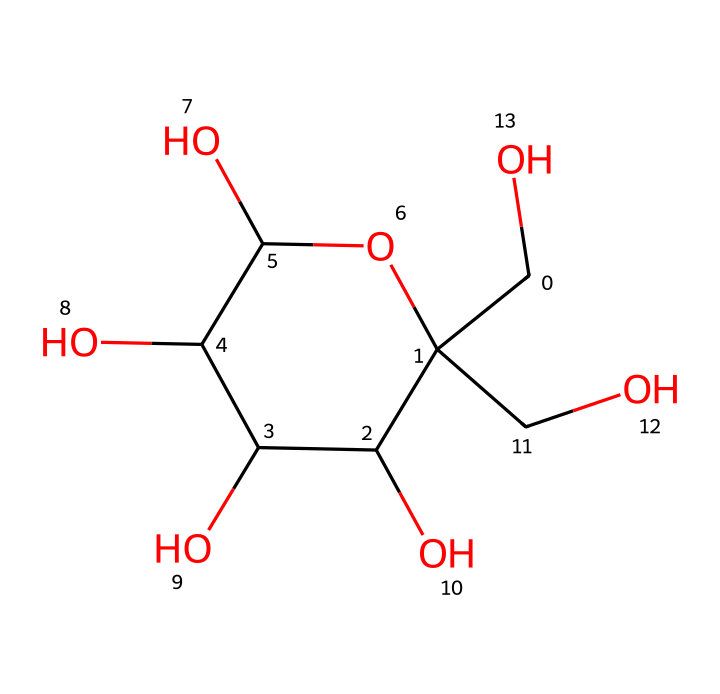What is the molecular formula of fructose? To determine the molecular formula from the SMILES representation, count the number of each type of atom present. The structure contains 6 carbon (C) atoms, 12 hydrogen (H) atoms, and 6 oxygen (O) atoms, which gives the formula C6H12O6.
Answer: C6H12O6 How many hydroxyl (–OH) groups are present in fructose? Examine the structure to identify the –OH (hydroxyl) groups. In the provided SMILES representation, there are 5 occurrences of –OH groups attached to carbon atoms, indicating that there are 5 hydroxyl groups.
Answer: 5 Is fructose a monosaccharide or a polysaccharide? Based on the structure, fructose consists of a single sugar unit, which classifies it as a monosaccharide. Polysaccharides are made up of multiple monosaccharide units linked together.
Answer: monosaccharide What type of carbohydrate is fructose categorized under? Fructose is categorized as a simple sugar, specifically a ketose, because it contains a ketone functional group in its structure and is a monomer of carbohydrates.
Answer: ketose How many chiral centers does fructose have? To determine the number of chiral centers, locate the carbon atoms that have four different substituents in the structure. Fructose has three chiral centers at carbons 3, 4, and 5, where each has different groups attached.
Answer: 3 What is one common use of fructose in beverages? Fructose is often used as a sweetener in energy drinks because it is sweeter than glucose and can enhance flavor without adding significant calories.
Answer: sweetener What effect does fructose have on blood sugar levels? Fructose has a lower glycemic index compared to glucose, meaning it causes a slower increase in blood sugar levels after consumption.
Answer: slower increase 